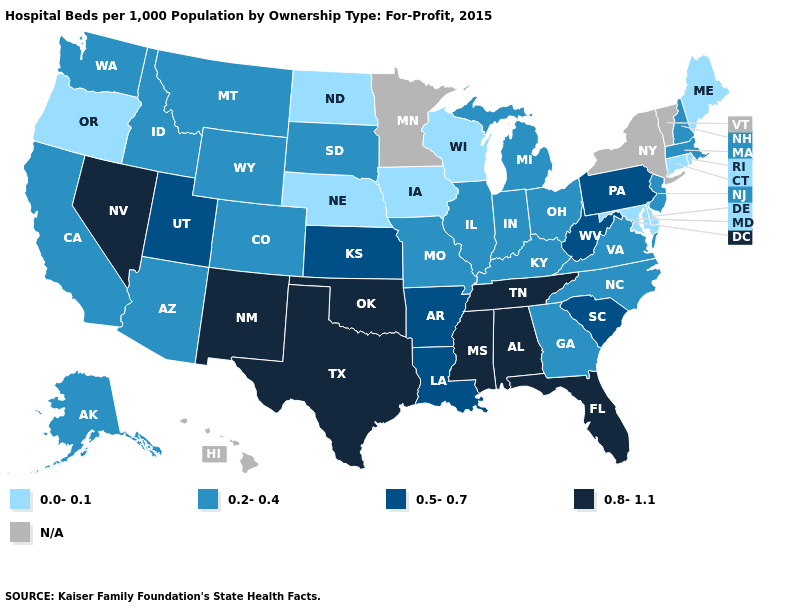What is the value of Nevada?
Quick response, please. 0.8-1.1. Name the states that have a value in the range 0.2-0.4?
Answer briefly. Alaska, Arizona, California, Colorado, Georgia, Idaho, Illinois, Indiana, Kentucky, Massachusetts, Michigan, Missouri, Montana, New Hampshire, New Jersey, North Carolina, Ohio, South Dakota, Virginia, Washington, Wyoming. Name the states that have a value in the range 0.2-0.4?
Give a very brief answer. Alaska, Arizona, California, Colorado, Georgia, Idaho, Illinois, Indiana, Kentucky, Massachusetts, Michigan, Missouri, Montana, New Hampshire, New Jersey, North Carolina, Ohio, South Dakota, Virginia, Washington, Wyoming. Does Alaska have the lowest value in the West?
Give a very brief answer. No. Which states have the highest value in the USA?
Short answer required. Alabama, Florida, Mississippi, Nevada, New Mexico, Oklahoma, Tennessee, Texas. What is the lowest value in the South?
Give a very brief answer. 0.0-0.1. What is the highest value in the Northeast ?
Keep it brief. 0.5-0.7. What is the highest value in the West ?
Short answer required. 0.8-1.1. Name the states that have a value in the range 0.5-0.7?
Give a very brief answer. Arkansas, Kansas, Louisiana, Pennsylvania, South Carolina, Utah, West Virginia. What is the highest value in states that border Virginia?
Concise answer only. 0.8-1.1. Is the legend a continuous bar?
Short answer required. No. What is the value of Maryland?
Answer briefly. 0.0-0.1. What is the highest value in the Northeast ?
Answer briefly. 0.5-0.7. Among the states that border West Virginia , which have the highest value?
Short answer required. Pennsylvania. What is the lowest value in the USA?
Quick response, please. 0.0-0.1. 